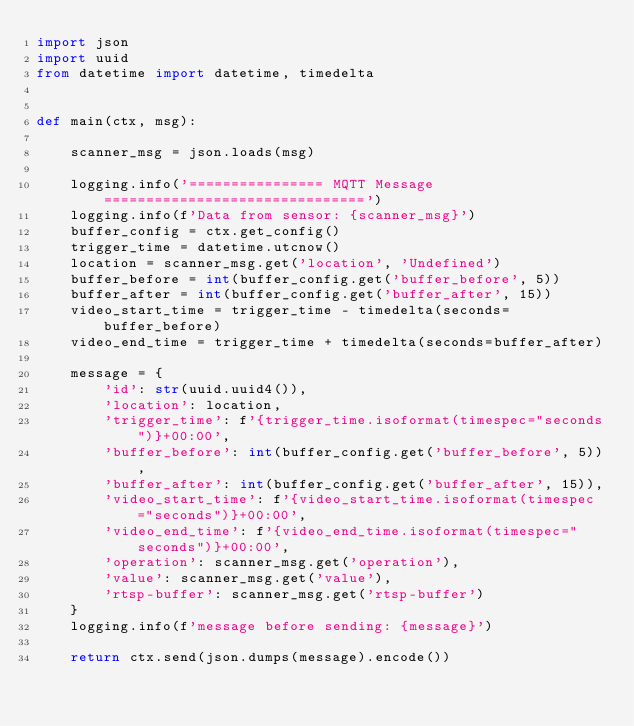Convert code to text. <code><loc_0><loc_0><loc_500><loc_500><_Python_>import json
import uuid
from datetime import datetime, timedelta


def main(ctx, msg):

    scanner_msg = json.loads(msg)

    logging.info('================ MQTT Message ===============================')    
    logging.info(f'Data from sensor: {scanner_msg}')
    buffer_config = ctx.get_config()
    trigger_time = datetime.utcnow()
    location = scanner_msg.get('location', 'Undefined')
    buffer_before = int(buffer_config.get('buffer_before', 5))
    buffer_after = int(buffer_config.get('buffer_after', 15))
    video_start_time = trigger_time - timedelta(seconds=buffer_before)
    video_end_time = trigger_time + timedelta(seconds=buffer_after)

    message = {
        'id': str(uuid.uuid4()),
        'location': location,
        'trigger_time': f'{trigger_time.isoformat(timespec="seconds")}+00:00',
        'buffer_before': int(buffer_config.get('buffer_before', 5)),
        'buffer_after': int(buffer_config.get('buffer_after', 15)),
        'video_start_time': f'{video_start_time.isoformat(timespec="seconds")}+00:00',
        'video_end_time': f'{video_end_time.isoformat(timespec="seconds")}+00:00',
        'operation': scanner_msg.get('operation'),
        'value': scanner_msg.get('value'),
        'rtsp-buffer': scanner_msg.get('rtsp-buffer')
    }
    logging.info(f'message before sending: {message}')
        
    return ctx.send(json.dumps(message).encode())
</code> 